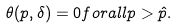Convert formula to latex. <formula><loc_0><loc_0><loc_500><loc_500>\theta ( p , \delta ) = 0 f o r a l l p > \hat { p } .</formula> 